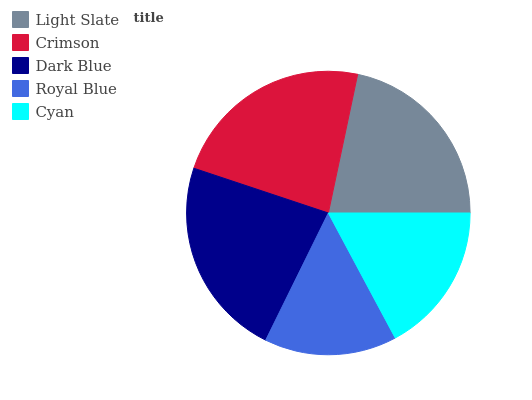Is Royal Blue the minimum?
Answer yes or no. Yes. Is Crimson the maximum?
Answer yes or no. Yes. Is Dark Blue the minimum?
Answer yes or no. No. Is Dark Blue the maximum?
Answer yes or no. No. Is Crimson greater than Dark Blue?
Answer yes or no. Yes. Is Dark Blue less than Crimson?
Answer yes or no. Yes. Is Dark Blue greater than Crimson?
Answer yes or no. No. Is Crimson less than Dark Blue?
Answer yes or no. No. Is Light Slate the high median?
Answer yes or no. Yes. Is Light Slate the low median?
Answer yes or no. Yes. Is Cyan the high median?
Answer yes or no. No. Is Royal Blue the low median?
Answer yes or no. No. 